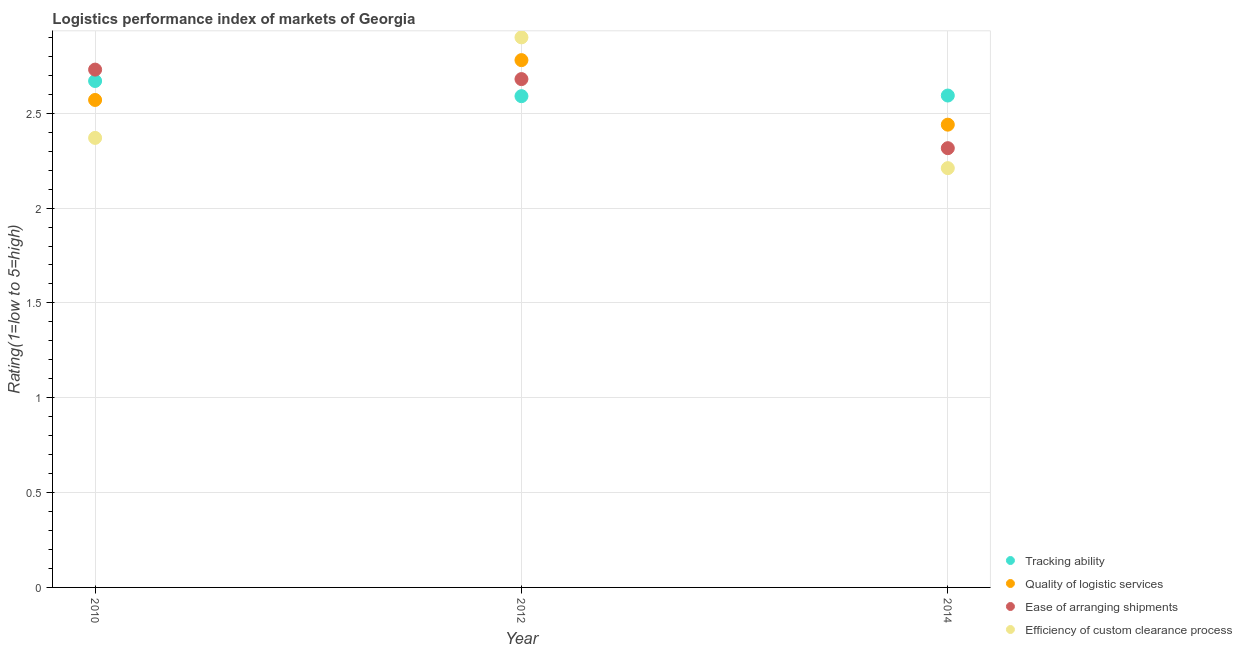How many different coloured dotlines are there?
Provide a short and direct response. 4. Is the number of dotlines equal to the number of legend labels?
Offer a very short reply. Yes. What is the lpi rating of quality of logistic services in 2010?
Give a very brief answer. 2.57. Across all years, what is the maximum lpi rating of ease of arranging shipments?
Your answer should be very brief. 2.73. Across all years, what is the minimum lpi rating of efficiency of custom clearance process?
Provide a short and direct response. 2.21. In which year was the lpi rating of quality of logistic services minimum?
Offer a terse response. 2014. What is the total lpi rating of quality of logistic services in the graph?
Make the answer very short. 7.79. What is the difference between the lpi rating of quality of logistic services in 2010 and that in 2014?
Provide a succinct answer. 0.13. What is the difference between the lpi rating of efficiency of custom clearance process in 2010 and the lpi rating of ease of arranging shipments in 2012?
Provide a short and direct response. -0.31. What is the average lpi rating of efficiency of custom clearance process per year?
Provide a short and direct response. 2.49. In the year 2012, what is the difference between the lpi rating of ease of arranging shipments and lpi rating of quality of logistic services?
Keep it short and to the point. -0.1. What is the ratio of the lpi rating of ease of arranging shipments in 2012 to that in 2014?
Keep it short and to the point. 1.16. Is the difference between the lpi rating of quality of logistic services in 2010 and 2012 greater than the difference between the lpi rating of tracking ability in 2010 and 2012?
Offer a very short reply. No. What is the difference between the highest and the second highest lpi rating of quality of logistic services?
Your response must be concise. 0.21. What is the difference between the highest and the lowest lpi rating of quality of logistic services?
Offer a terse response. 0.34. In how many years, is the lpi rating of quality of logistic services greater than the average lpi rating of quality of logistic services taken over all years?
Keep it short and to the point. 1. Is it the case that in every year, the sum of the lpi rating of tracking ability and lpi rating of quality of logistic services is greater than the lpi rating of ease of arranging shipments?
Keep it short and to the point. Yes. Does the lpi rating of ease of arranging shipments monotonically increase over the years?
Your response must be concise. No. Is the lpi rating of efficiency of custom clearance process strictly less than the lpi rating of ease of arranging shipments over the years?
Make the answer very short. No. How many dotlines are there?
Offer a terse response. 4. How many years are there in the graph?
Make the answer very short. 3. What is the difference between two consecutive major ticks on the Y-axis?
Offer a very short reply. 0.5. Are the values on the major ticks of Y-axis written in scientific E-notation?
Give a very brief answer. No. Does the graph contain any zero values?
Provide a short and direct response. No. Does the graph contain grids?
Ensure brevity in your answer.  Yes. Where does the legend appear in the graph?
Give a very brief answer. Bottom right. What is the title of the graph?
Offer a terse response. Logistics performance index of markets of Georgia. What is the label or title of the Y-axis?
Ensure brevity in your answer.  Rating(1=low to 5=high). What is the Rating(1=low to 5=high) in Tracking ability in 2010?
Your response must be concise. 2.67. What is the Rating(1=low to 5=high) of Quality of logistic services in 2010?
Give a very brief answer. 2.57. What is the Rating(1=low to 5=high) of Ease of arranging shipments in 2010?
Your answer should be very brief. 2.73. What is the Rating(1=low to 5=high) of Efficiency of custom clearance process in 2010?
Ensure brevity in your answer.  2.37. What is the Rating(1=low to 5=high) in Tracking ability in 2012?
Make the answer very short. 2.59. What is the Rating(1=low to 5=high) in Quality of logistic services in 2012?
Keep it short and to the point. 2.78. What is the Rating(1=low to 5=high) in Ease of arranging shipments in 2012?
Offer a very short reply. 2.68. What is the Rating(1=low to 5=high) in Efficiency of custom clearance process in 2012?
Your answer should be compact. 2.9. What is the Rating(1=low to 5=high) of Tracking ability in 2014?
Make the answer very short. 2.59. What is the Rating(1=low to 5=high) of Quality of logistic services in 2014?
Provide a succinct answer. 2.44. What is the Rating(1=low to 5=high) in Ease of arranging shipments in 2014?
Offer a very short reply. 2.32. What is the Rating(1=low to 5=high) in Efficiency of custom clearance process in 2014?
Provide a short and direct response. 2.21. Across all years, what is the maximum Rating(1=low to 5=high) of Tracking ability?
Offer a terse response. 2.67. Across all years, what is the maximum Rating(1=low to 5=high) in Quality of logistic services?
Your answer should be compact. 2.78. Across all years, what is the maximum Rating(1=low to 5=high) of Ease of arranging shipments?
Keep it short and to the point. 2.73. Across all years, what is the maximum Rating(1=low to 5=high) of Efficiency of custom clearance process?
Ensure brevity in your answer.  2.9. Across all years, what is the minimum Rating(1=low to 5=high) of Tracking ability?
Keep it short and to the point. 2.59. Across all years, what is the minimum Rating(1=low to 5=high) of Quality of logistic services?
Offer a very short reply. 2.44. Across all years, what is the minimum Rating(1=low to 5=high) of Ease of arranging shipments?
Your response must be concise. 2.32. Across all years, what is the minimum Rating(1=low to 5=high) of Efficiency of custom clearance process?
Offer a very short reply. 2.21. What is the total Rating(1=low to 5=high) in Tracking ability in the graph?
Your answer should be compact. 7.85. What is the total Rating(1=low to 5=high) in Quality of logistic services in the graph?
Ensure brevity in your answer.  7.79. What is the total Rating(1=low to 5=high) of Ease of arranging shipments in the graph?
Offer a very short reply. 7.73. What is the total Rating(1=low to 5=high) in Efficiency of custom clearance process in the graph?
Ensure brevity in your answer.  7.48. What is the difference between the Rating(1=low to 5=high) in Quality of logistic services in 2010 and that in 2012?
Your response must be concise. -0.21. What is the difference between the Rating(1=low to 5=high) in Ease of arranging shipments in 2010 and that in 2012?
Offer a terse response. 0.05. What is the difference between the Rating(1=low to 5=high) of Efficiency of custom clearance process in 2010 and that in 2012?
Offer a very short reply. -0.53. What is the difference between the Rating(1=low to 5=high) of Tracking ability in 2010 and that in 2014?
Offer a very short reply. 0.08. What is the difference between the Rating(1=low to 5=high) in Quality of logistic services in 2010 and that in 2014?
Offer a very short reply. 0.13. What is the difference between the Rating(1=low to 5=high) in Ease of arranging shipments in 2010 and that in 2014?
Keep it short and to the point. 0.41. What is the difference between the Rating(1=low to 5=high) in Efficiency of custom clearance process in 2010 and that in 2014?
Provide a short and direct response. 0.16. What is the difference between the Rating(1=low to 5=high) in Tracking ability in 2012 and that in 2014?
Your answer should be compact. -0. What is the difference between the Rating(1=low to 5=high) in Quality of logistic services in 2012 and that in 2014?
Offer a terse response. 0.34. What is the difference between the Rating(1=low to 5=high) in Ease of arranging shipments in 2012 and that in 2014?
Provide a succinct answer. 0.36. What is the difference between the Rating(1=low to 5=high) of Efficiency of custom clearance process in 2012 and that in 2014?
Give a very brief answer. 0.69. What is the difference between the Rating(1=low to 5=high) in Tracking ability in 2010 and the Rating(1=low to 5=high) in Quality of logistic services in 2012?
Give a very brief answer. -0.11. What is the difference between the Rating(1=low to 5=high) in Tracking ability in 2010 and the Rating(1=low to 5=high) in Ease of arranging shipments in 2012?
Offer a terse response. -0.01. What is the difference between the Rating(1=low to 5=high) in Tracking ability in 2010 and the Rating(1=low to 5=high) in Efficiency of custom clearance process in 2012?
Offer a terse response. -0.23. What is the difference between the Rating(1=low to 5=high) in Quality of logistic services in 2010 and the Rating(1=low to 5=high) in Ease of arranging shipments in 2012?
Your response must be concise. -0.11. What is the difference between the Rating(1=low to 5=high) of Quality of logistic services in 2010 and the Rating(1=low to 5=high) of Efficiency of custom clearance process in 2012?
Keep it short and to the point. -0.33. What is the difference between the Rating(1=low to 5=high) in Ease of arranging shipments in 2010 and the Rating(1=low to 5=high) in Efficiency of custom clearance process in 2012?
Offer a terse response. -0.17. What is the difference between the Rating(1=low to 5=high) of Tracking ability in 2010 and the Rating(1=low to 5=high) of Quality of logistic services in 2014?
Your answer should be very brief. 0.23. What is the difference between the Rating(1=low to 5=high) in Tracking ability in 2010 and the Rating(1=low to 5=high) in Ease of arranging shipments in 2014?
Keep it short and to the point. 0.35. What is the difference between the Rating(1=low to 5=high) in Tracking ability in 2010 and the Rating(1=low to 5=high) in Efficiency of custom clearance process in 2014?
Your answer should be compact. 0.46. What is the difference between the Rating(1=low to 5=high) of Quality of logistic services in 2010 and the Rating(1=low to 5=high) of Ease of arranging shipments in 2014?
Ensure brevity in your answer.  0.25. What is the difference between the Rating(1=low to 5=high) of Quality of logistic services in 2010 and the Rating(1=low to 5=high) of Efficiency of custom clearance process in 2014?
Make the answer very short. 0.36. What is the difference between the Rating(1=low to 5=high) in Ease of arranging shipments in 2010 and the Rating(1=low to 5=high) in Efficiency of custom clearance process in 2014?
Offer a terse response. 0.52. What is the difference between the Rating(1=low to 5=high) in Tracking ability in 2012 and the Rating(1=low to 5=high) in Quality of logistic services in 2014?
Offer a terse response. 0.15. What is the difference between the Rating(1=low to 5=high) of Tracking ability in 2012 and the Rating(1=low to 5=high) of Ease of arranging shipments in 2014?
Your answer should be very brief. 0.27. What is the difference between the Rating(1=low to 5=high) in Tracking ability in 2012 and the Rating(1=low to 5=high) in Efficiency of custom clearance process in 2014?
Offer a terse response. 0.38. What is the difference between the Rating(1=low to 5=high) in Quality of logistic services in 2012 and the Rating(1=low to 5=high) in Ease of arranging shipments in 2014?
Keep it short and to the point. 0.46. What is the difference between the Rating(1=low to 5=high) of Quality of logistic services in 2012 and the Rating(1=low to 5=high) of Efficiency of custom clearance process in 2014?
Your answer should be compact. 0.57. What is the difference between the Rating(1=low to 5=high) in Ease of arranging shipments in 2012 and the Rating(1=low to 5=high) in Efficiency of custom clearance process in 2014?
Make the answer very short. 0.47. What is the average Rating(1=low to 5=high) in Tracking ability per year?
Offer a very short reply. 2.62. What is the average Rating(1=low to 5=high) in Quality of logistic services per year?
Provide a short and direct response. 2.6. What is the average Rating(1=low to 5=high) in Ease of arranging shipments per year?
Your answer should be very brief. 2.58. What is the average Rating(1=low to 5=high) in Efficiency of custom clearance process per year?
Offer a terse response. 2.49. In the year 2010, what is the difference between the Rating(1=low to 5=high) in Tracking ability and Rating(1=low to 5=high) in Quality of logistic services?
Keep it short and to the point. 0.1. In the year 2010, what is the difference between the Rating(1=low to 5=high) in Tracking ability and Rating(1=low to 5=high) in Ease of arranging shipments?
Your response must be concise. -0.06. In the year 2010, what is the difference between the Rating(1=low to 5=high) in Quality of logistic services and Rating(1=low to 5=high) in Ease of arranging shipments?
Ensure brevity in your answer.  -0.16. In the year 2010, what is the difference between the Rating(1=low to 5=high) of Ease of arranging shipments and Rating(1=low to 5=high) of Efficiency of custom clearance process?
Your answer should be very brief. 0.36. In the year 2012, what is the difference between the Rating(1=low to 5=high) in Tracking ability and Rating(1=low to 5=high) in Quality of logistic services?
Your answer should be very brief. -0.19. In the year 2012, what is the difference between the Rating(1=low to 5=high) in Tracking ability and Rating(1=low to 5=high) in Ease of arranging shipments?
Ensure brevity in your answer.  -0.09. In the year 2012, what is the difference between the Rating(1=low to 5=high) of Tracking ability and Rating(1=low to 5=high) of Efficiency of custom clearance process?
Keep it short and to the point. -0.31. In the year 2012, what is the difference between the Rating(1=low to 5=high) of Quality of logistic services and Rating(1=low to 5=high) of Ease of arranging shipments?
Ensure brevity in your answer.  0.1. In the year 2012, what is the difference between the Rating(1=low to 5=high) of Quality of logistic services and Rating(1=low to 5=high) of Efficiency of custom clearance process?
Your answer should be compact. -0.12. In the year 2012, what is the difference between the Rating(1=low to 5=high) in Ease of arranging shipments and Rating(1=low to 5=high) in Efficiency of custom clearance process?
Offer a terse response. -0.22. In the year 2014, what is the difference between the Rating(1=low to 5=high) of Tracking ability and Rating(1=low to 5=high) of Quality of logistic services?
Offer a terse response. 0.15. In the year 2014, what is the difference between the Rating(1=low to 5=high) in Tracking ability and Rating(1=low to 5=high) in Ease of arranging shipments?
Your response must be concise. 0.28. In the year 2014, what is the difference between the Rating(1=low to 5=high) in Tracking ability and Rating(1=low to 5=high) in Efficiency of custom clearance process?
Give a very brief answer. 0.38. In the year 2014, what is the difference between the Rating(1=low to 5=high) of Quality of logistic services and Rating(1=low to 5=high) of Ease of arranging shipments?
Provide a short and direct response. 0.12. In the year 2014, what is the difference between the Rating(1=low to 5=high) of Quality of logistic services and Rating(1=low to 5=high) of Efficiency of custom clearance process?
Give a very brief answer. 0.23. In the year 2014, what is the difference between the Rating(1=low to 5=high) in Ease of arranging shipments and Rating(1=low to 5=high) in Efficiency of custom clearance process?
Keep it short and to the point. 0.11. What is the ratio of the Rating(1=low to 5=high) in Tracking ability in 2010 to that in 2012?
Ensure brevity in your answer.  1.03. What is the ratio of the Rating(1=low to 5=high) in Quality of logistic services in 2010 to that in 2012?
Offer a terse response. 0.92. What is the ratio of the Rating(1=low to 5=high) of Ease of arranging shipments in 2010 to that in 2012?
Provide a short and direct response. 1.02. What is the ratio of the Rating(1=low to 5=high) of Efficiency of custom clearance process in 2010 to that in 2012?
Offer a very short reply. 0.82. What is the ratio of the Rating(1=low to 5=high) of Tracking ability in 2010 to that in 2014?
Ensure brevity in your answer.  1.03. What is the ratio of the Rating(1=low to 5=high) of Quality of logistic services in 2010 to that in 2014?
Offer a very short reply. 1.05. What is the ratio of the Rating(1=low to 5=high) in Ease of arranging shipments in 2010 to that in 2014?
Keep it short and to the point. 1.18. What is the ratio of the Rating(1=low to 5=high) of Efficiency of custom clearance process in 2010 to that in 2014?
Ensure brevity in your answer.  1.07. What is the ratio of the Rating(1=low to 5=high) in Tracking ability in 2012 to that in 2014?
Provide a succinct answer. 1. What is the ratio of the Rating(1=low to 5=high) in Quality of logistic services in 2012 to that in 2014?
Keep it short and to the point. 1.14. What is the ratio of the Rating(1=low to 5=high) of Ease of arranging shipments in 2012 to that in 2014?
Provide a short and direct response. 1.16. What is the ratio of the Rating(1=low to 5=high) in Efficiency of custom clearance process in 2012 to that in 2014?
Provide a succinct answer. 1.31. What is the difference between the highest and the second highest Rating(1=low to 5=high) of Tracking ability?
Provide a succinct answer. 0.08. What is the difference between the highest and the second highest Rating(1=low to 5=high) in Quality of logistic services?
Provide a short and direct response. 0.21. What is the difference between the highest and the second highest Rating(1=low to 5=high) in Efficiency of custom clearance process?
Ensure brevity in your answer.  0.53. What is the difference between the highest and the lowest Rating(1=low to 5=high) of Tracking ability?
Your answer should be very brief. 0.08. What is the difference between the highest and the lowest Rating(1=low to 5=high) of Quality of logistic services?
Keep it short and to the point. 0.34. What is the difference between the highest and the lowest Rating(1=low to 5=high) of Ease of arranging shipments?
Give a very brief answer. 0.41. What is the difference between the highest and the lowest Rating(1=low to 5=high) in Efficiency of custom clearance process?
Ensure brevity in your answer.  0.69. 